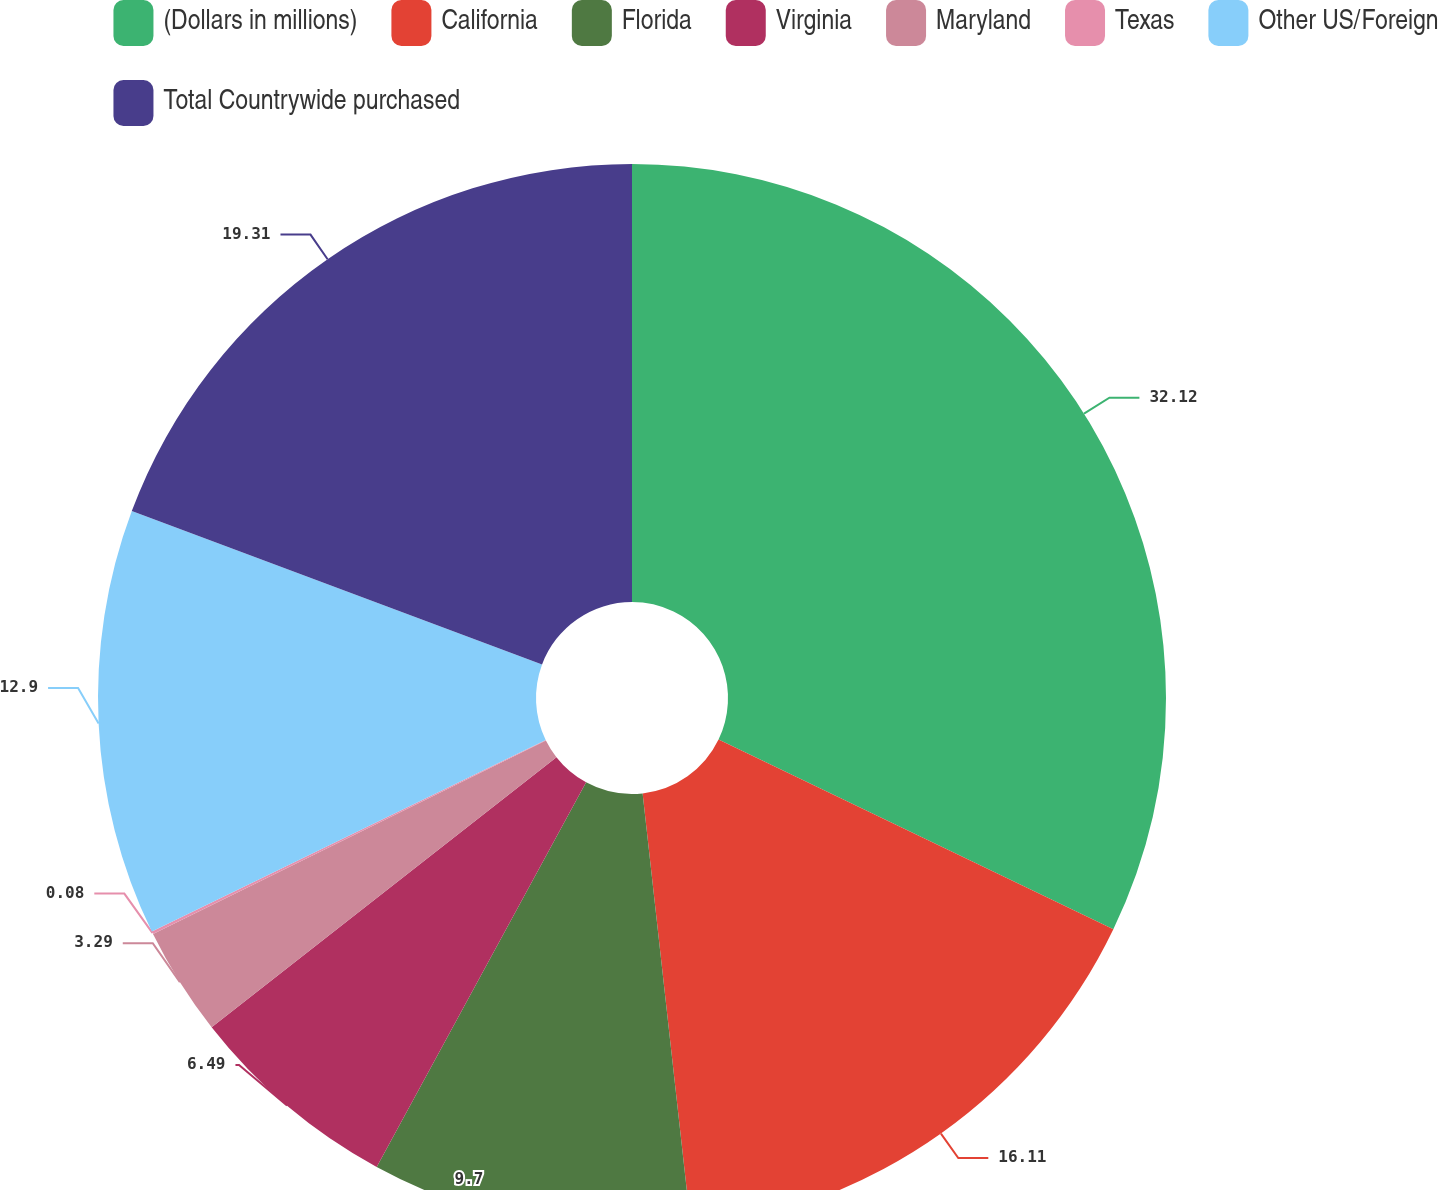Convert chart to OTSL. <chart><loc_0><loc_0><loc_500><loc_500><pie_chart><fcel>(Dollars in millions)<fcel>California<fcel>Florida<fcel>Virginia<fcel>Maryland<fcel>Texas<fcel>Other US/Foreign<fcel>Total Countrywide purchased<nl><fcel>32.13%<fcel>16.11%<fcel>9.7%<fcel>6.49%<fcel>3.29%<fcel>0.08%<fcel>12.9%<fcel>19.31%<nl></chart> 